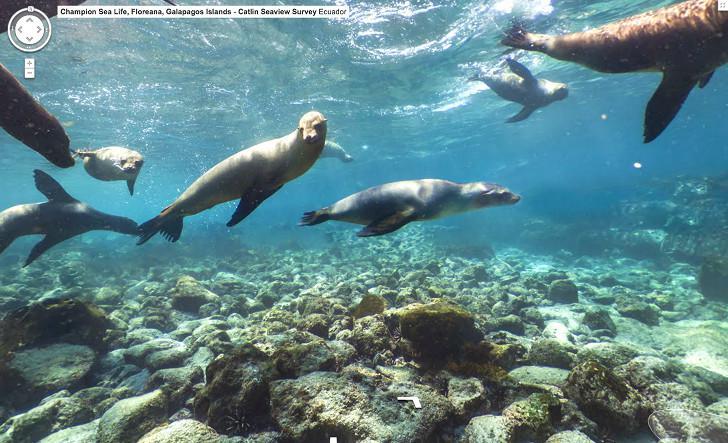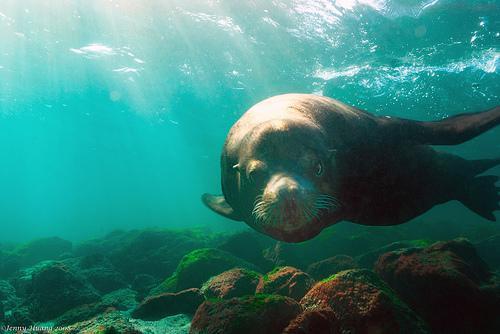The first image is the image on the left, the second image is the image on the right. Evaluate the accuracy of this statement regarding the images: "A person is swimming with the animals in the image on the left.". Is it true? Answer yes or no. No. The first image is the image on the left, the second image is the image on the right. Evaluate the accuracy of this statement regarding the images: "An image includes at least one human diver swimming in the vicinity of a seal.". Is it true? Answer yes or no. No. 